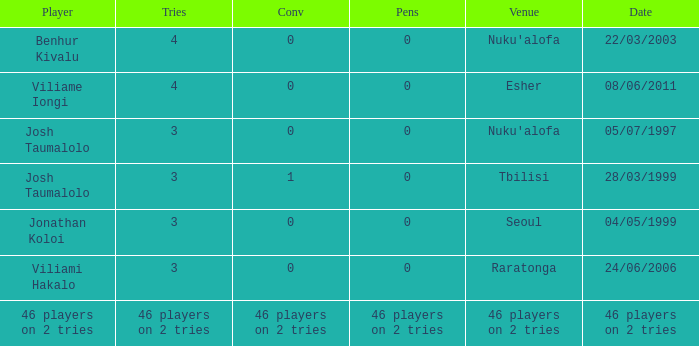What date did Josh Taumalolo play at Nuku'alofa? 05/07/1997. 